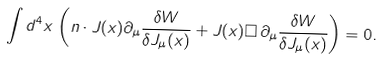Convert formula to latex. <formula><loc_0><loc_0><loc_500><loc_500>\int d ^ { 4 } x \, \left ( n \cdot J ( x ) \partial _ { \mu } \frac { \delta W } { \delta J _ { \mu } ( x ) } + J ( x ) \Box \, \partial _ { \mu } \frac { \delta W } { \delta J _ { \mu } ( x ) } \right ) = 0 .</formula> 